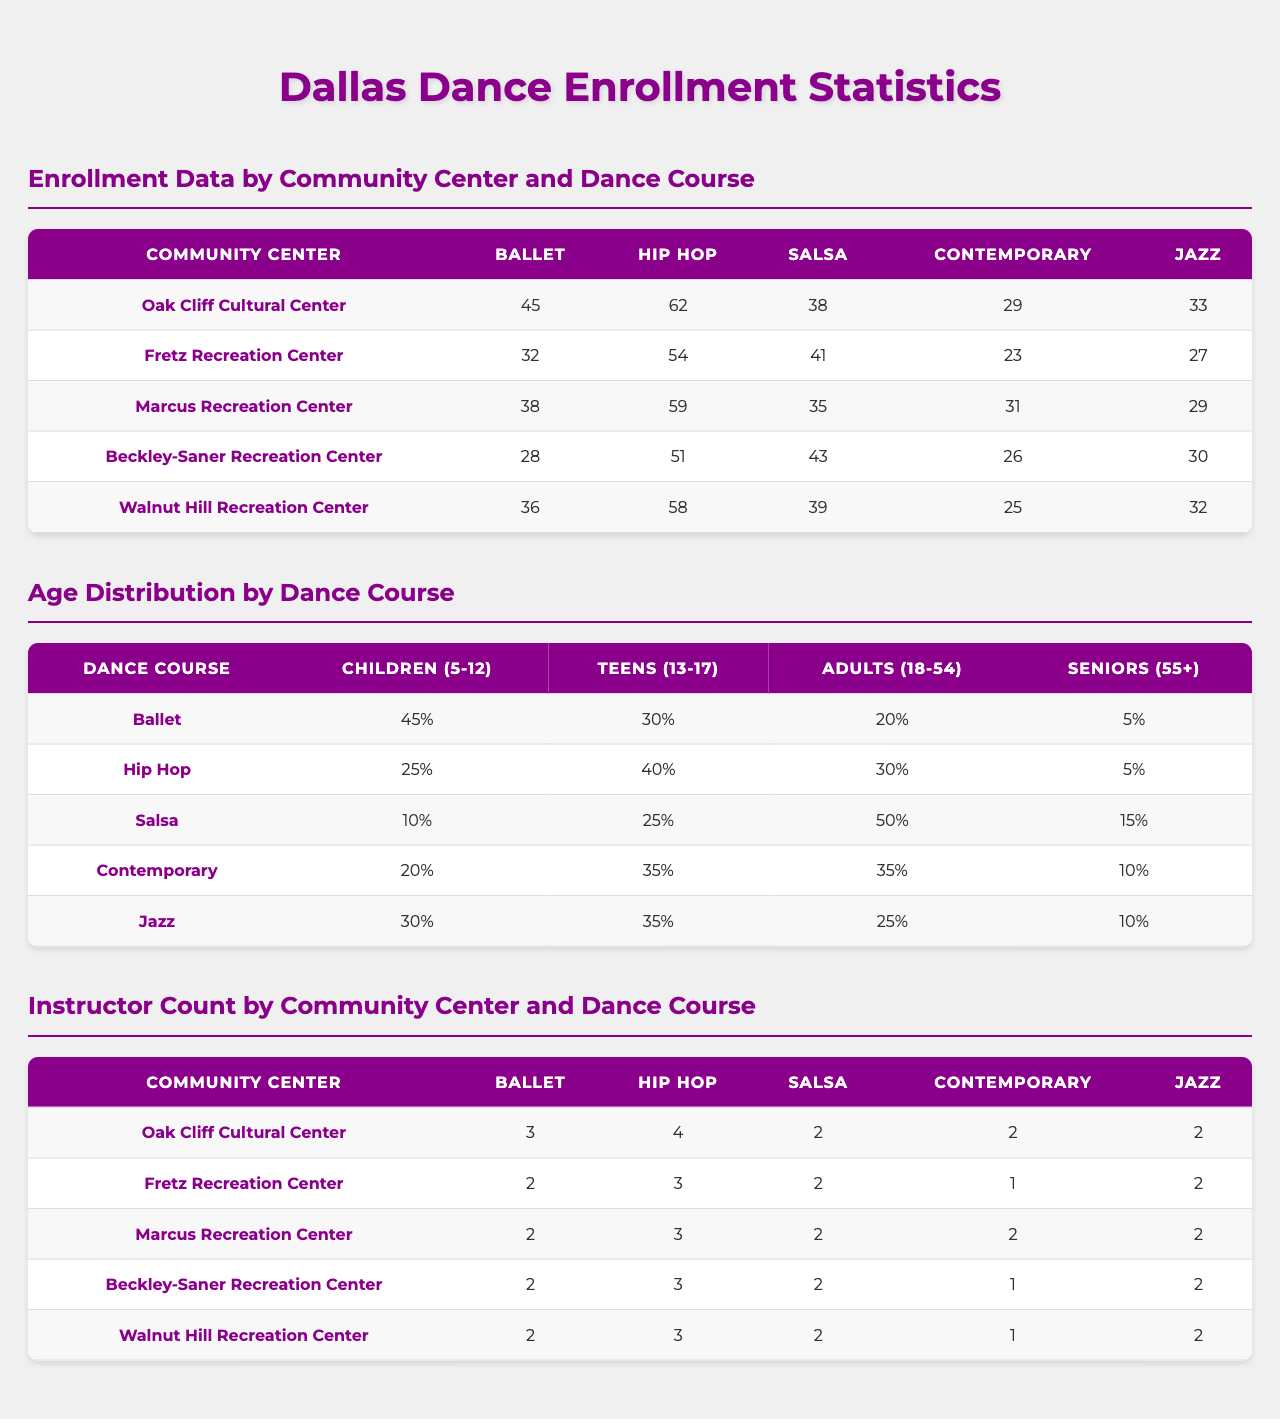What is the total enrollment for Salsa classes at all community centers? To find the total enrollment for Salsa classes, I need to sum the enrollment numbers for Salsa across all community centers: 38 (Oak Cliff) + 41 (Fretz) + 35 (Marcus) + 43 (Beckley-Saner) + 39 (Walnut Hill) = 196.
Answer: 196 Which community center has the highest enrollment for Contemporary dance? I need to check the enrollment numbers for Contemporary at each community center: Oak Cliff (29), Fretz (23), Marcus (31), Beckley-Saner (26), Walnut Hill (25). The highest enrollment is at Marcus Recreation Center with 31.
Answer: Marcus Recreation Center What percentage of Seniors (55+) are enrolled in Hip Hop dance? From the age distribution for Hip Hop, there are 5 Seniors out of a total of 100 enrolled dancers (25 children + 40 teens + 30 adults + 5 seniors). The percentage is calculated as (5/100) * 100% = 5%.
Answer: 5% Which dance course has the highest enrollment among Adults (18-54)? The enrollment numbers for Adults are: Ballet (20), Hip Hop (30), Salsa (50), Contemporary (35), and Jazz (25). Salsa has the highest enrollment with 50.
Answer: Salsa Is there a community center that has no instructors for Contemporary dance? Checking the instructor counts, I see that Oak Cliff has 2, Fretz has 1, Marcus has 2, Beckley-Saner has 1, and Walnut Hill has 1 instructor for Contemporary. Yes, Fretz, Beckley-Saner, and Walnut Hill have only 1 instructor.
Answer: Yes What is the average number of instructors for Hip Hop across all community centers? The instructor counts for Hip Hop are: 4 (Oak Cliff), 3 (Fretz), 3 (Marcus), 3 (Beckley-Saner), and 3 (Walnut Hill). Summing them gives 4 + 3 + 3 + 3 + 3 = 16. The average is 16/5 = 3.2.
Answer: 3.2 Which dance course has the largest percentage of Children (5-12) enrolled? The percentages for Children are: Ballet (45%), Hip Hop (25%), Salsa (10%), Contemporary (20%), Jazz (30%). Ballet has the largest percentage with 45%.
Answer: Ballet What is the combined enrollment for Ballet and Jazz at Walnut Hill Recreation Center? The enrollment for Ballet at Walnut Hill is 36 and for Jazz it's 32. Adding them gives 36 + 32 = 68.
Answer: 68 How does the total enrollment for Hip Hop at all centers compare to that of Salsa? The total enrollment for Hip Hop is 62 (Oak Cliff) + 54 (Fretz) + 59 (Marcus) + 51 (Beckley-Saner) + 58 (Walnut Hill) = 284. For Salsa, the total is 196 (from a previous question). 284 > 196 shows that Hip Hop has higher enrollment.
Answer: Hip Hop has higher enrollment Is it true that more than half of the enrollment in Jazz classes at Fretz Recreation Center is made up of Teens (13-17)? The enrollment in Jazz at Fretz is 27, of which the Teens count is 35%. The actual number of Teens is 27 * 0.35 = 9.45, which is not more than half (which would be 13.5).
Answer: No 